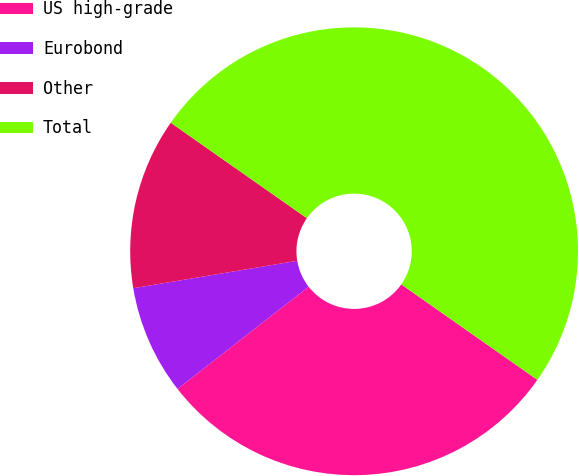Convert chart. <chart><loc_0><loc_0><loc_500><loc_500><pie_chart><fcel>US high-grade<fcel>Eurobond<fcel>Other<fcel>Total<nl><fcel>29.72%<fcel>7.9%<fcel>12.37%<fcel>50.0%<nl></chart> 